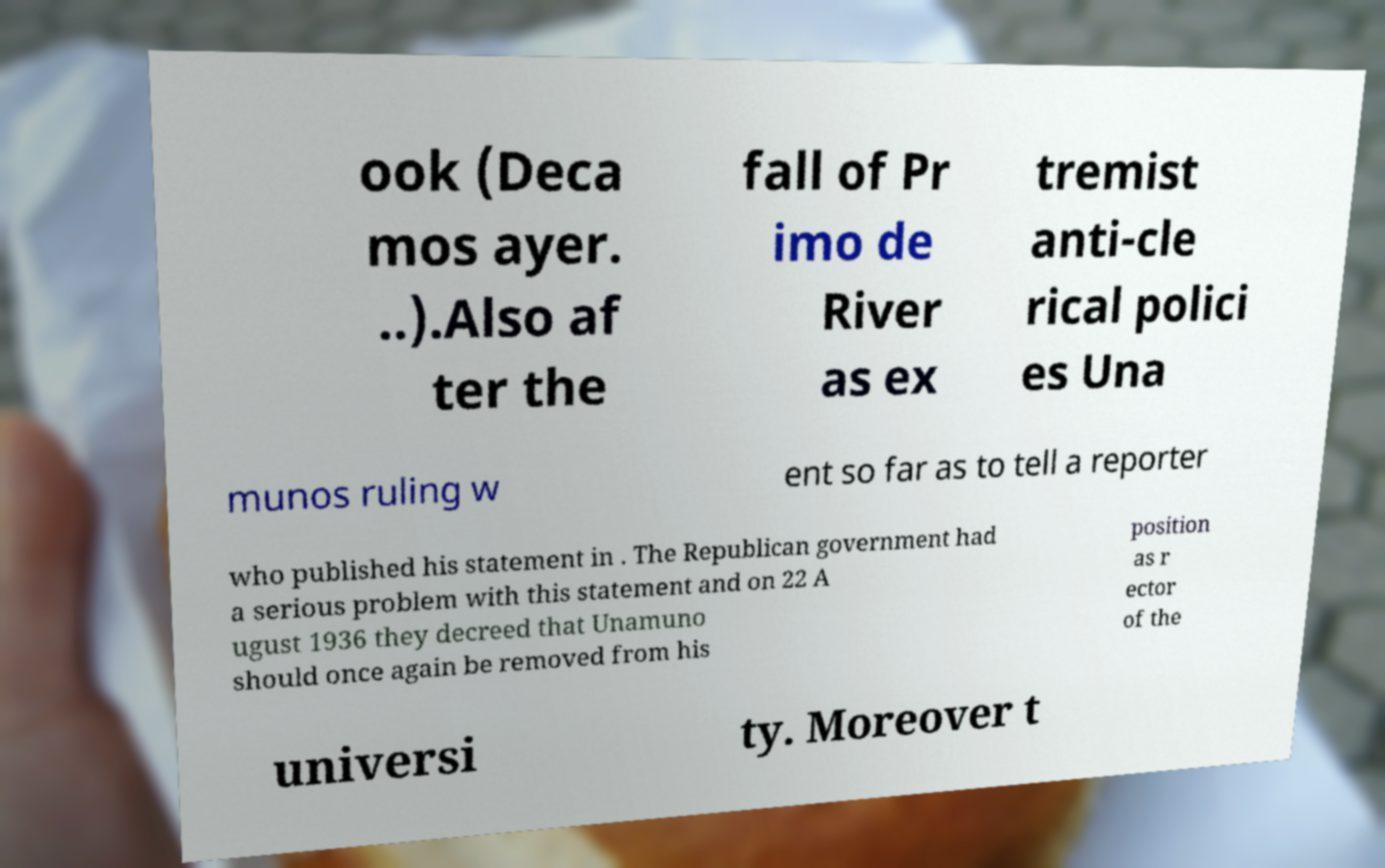Could you extract and type out the text from this image? ook (Deca mos ayer. ..).Also af ter the fall of Pr imo de River as ex tremist anti-cle rical polici es Una munos ruling w ent so far as to tell a reporter who published his statement in . The Republican government had a serious problem with this statement and on 22 A ugust 1936 they decreed that Unamuno should once again be removed from his position as r ector of the universi ty. Moreover t 